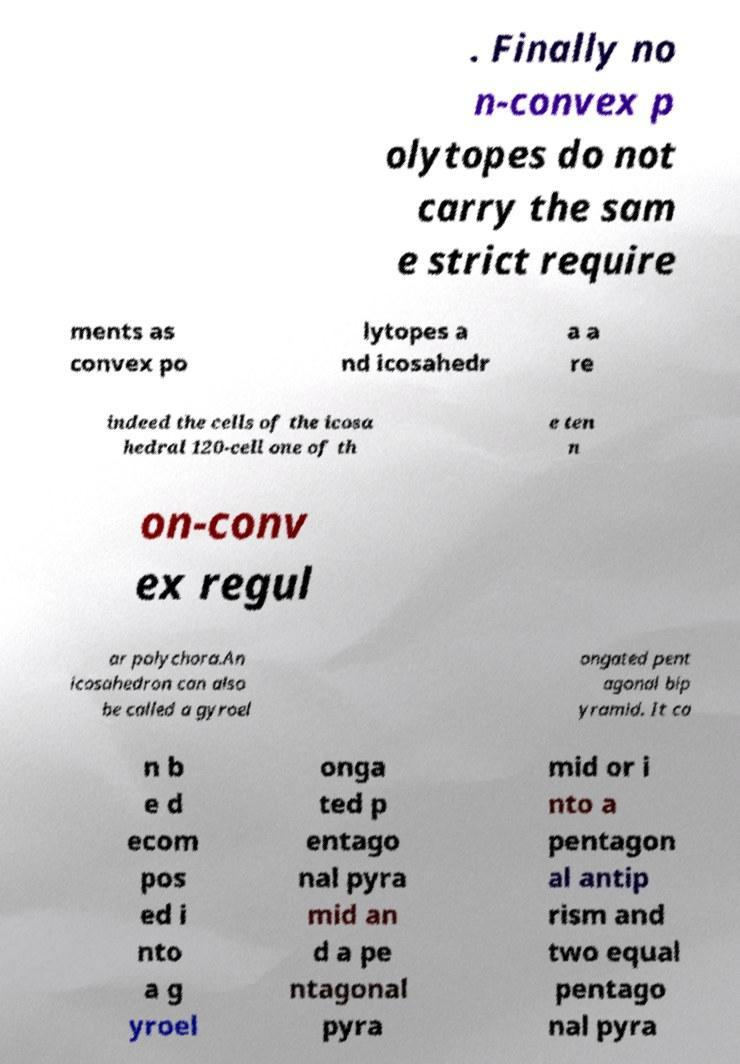Please identify and transcribe the text found in this image. . Finally no n-convex p olytopes do not carry the sam e strict require ments as convex po lytopes a nd icosahedr a a re indeed the cells of the icosa hedral 120-cell one of th e ten n on-conv ex regul ar polychora.An icosahedron can also be called a gyroel ongated pent agonal bip yramid. It ca n b e d ecom pos ed i nto a g yroel onga ted p entago nal pyra mid an d a pe ntagonal pyra mid or i nto a pentagon al antip rism and two equal pentago nal pyra 